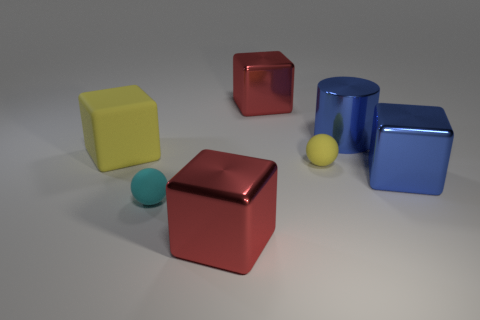The other tiny object that is the same shape as the small yellow thing is what color?
Keep it short and to the point. Cyan. Are there any shiny cylinders that are in front of the rubber object left of the small matte thing to the left of the tiny yellow matte ball?
Ensure brevity in your answer.  No. Is the shape of the cyan object the same as the tiny yellow thing?
Ensure brevity in your answer.  Yes. Are there fewer large red blocks behind the yellow matte sphere than big gray shiny objects?
Give a very brief answer. No. What color is the metal cube that is behind the yellow rubber object to the left of the red block that is behind the cyan sphere?
Your answer should be compact. Red. What number of metallic objects are large red spheres or cubes?
Your answer should be very brief. 3. Does the cyan matte object have the same size as the yellow matte sphere?
Provide a succinct answer. Yes. Is the number of cylinders in front of the big blue metal cylinder less than the number of metallic objects that are behind the big blue cube?
Provide a succinct answer. Yes. The cyan matte ball is what size?
Give a very brief answer. Small. How many large objects are either rubber cubes or cubes?
Offer a very short reply. 4. 